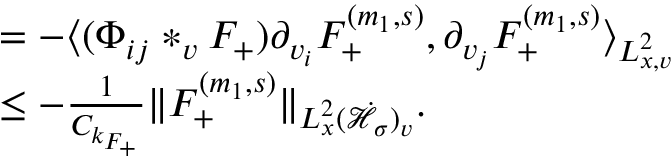<formula> <loc_0><loc_0><loc_500><loc_500>\begin{array} { r l } & { = - \langle ( \Phi _ { i j } * _ { v } F _ { + } ) \partial _ { v _ { i } } F _ { + } ^ { ( m _ { 1 } , s ) } , \partial _ { v _ { j } } F _ { + } ^ { ( m _ { 1 } , s ) } \rangle _ { L _ { x , v } ^ { 2 } } } \\ & { \leq - \frac { 1 } { C _ { k _ { F _ { + } } } } \| F _ { + } ^ { ( m _ { 1 } , s ) } \| _ { L _ { x } ^ { 2 } ( \dot { \mathcal { H } } _ { \sigma } ) _ { v } } . } \end{array}</formula> 